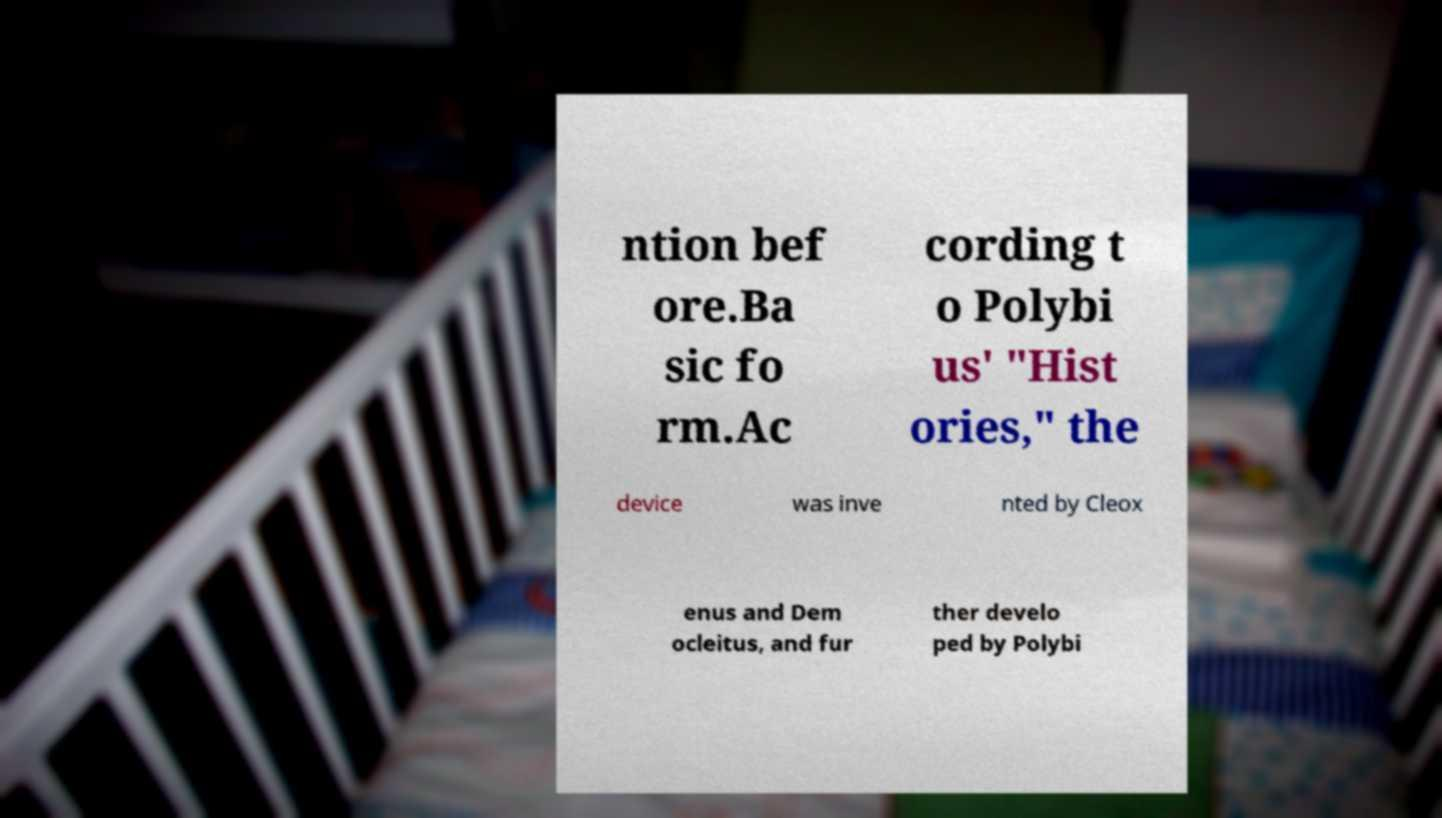Could you assist in decoding the text presented in this image and type it out clearly? ntion bef ore.Ba sic fo rm.Ac cording t o Polybi us' "Hist ories," the device was inve nted by Cleox enus and Dem ocleitus, and fur ther develo ped by Polybi 